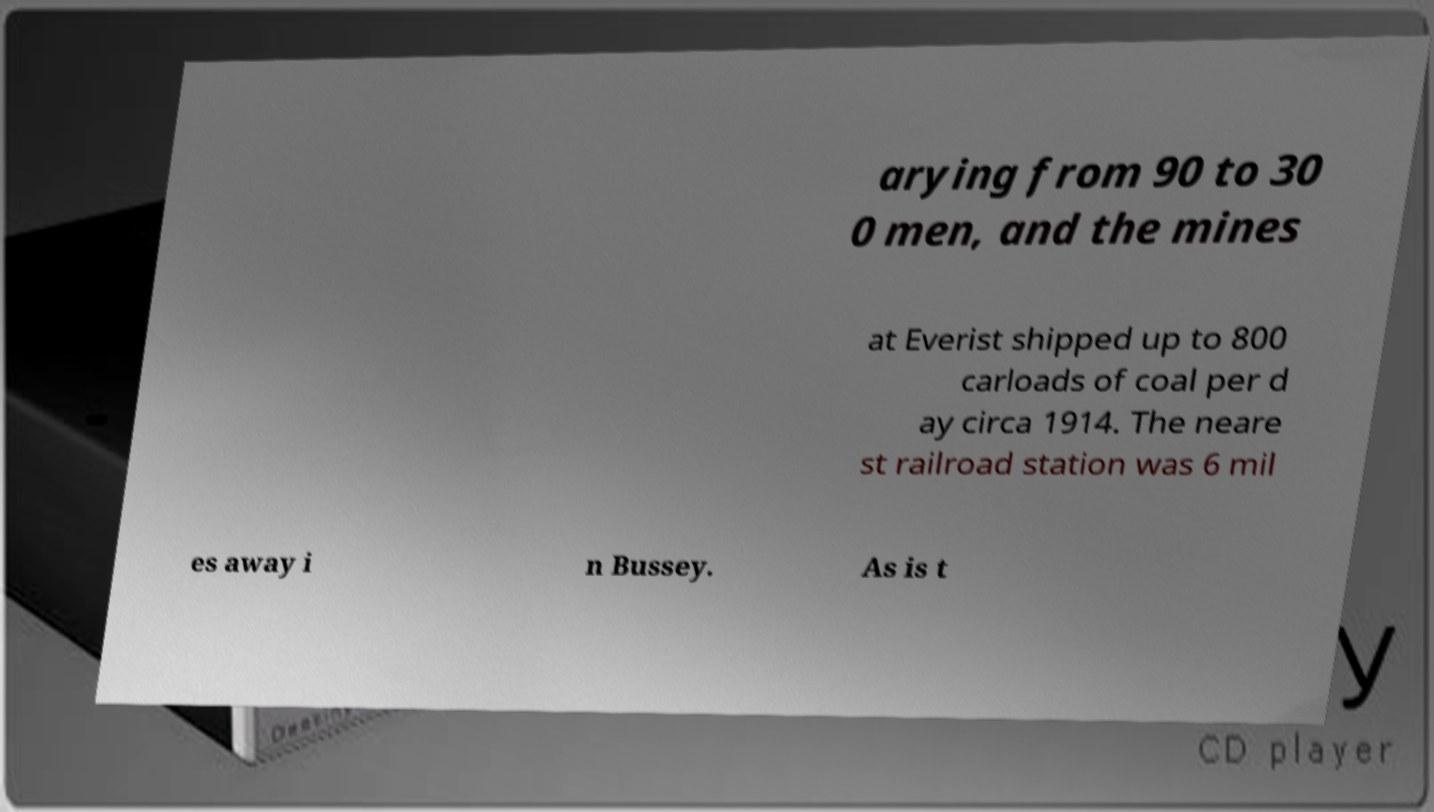For documentation purposes, I need the text within this image transcribed. Could you provide that? arying from 90 to 30 0 men, and the mines at Everist shipped up to 800 carloads of coal per d ay circa 1914. The neare st railroad station was 6 mil es away i n Bussey. As is t 